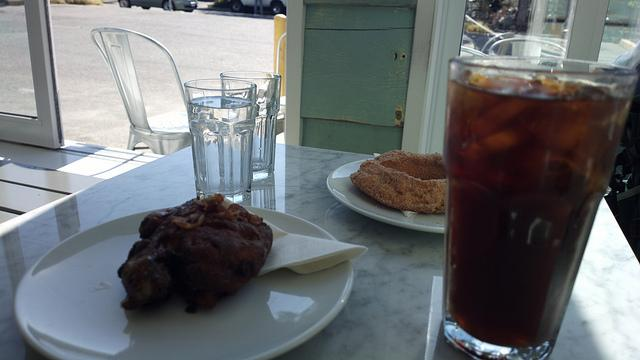Which object would have the least amount of flavors in it? Please explain your reasoning. water glass. Water can seem to be basically flavorless. 